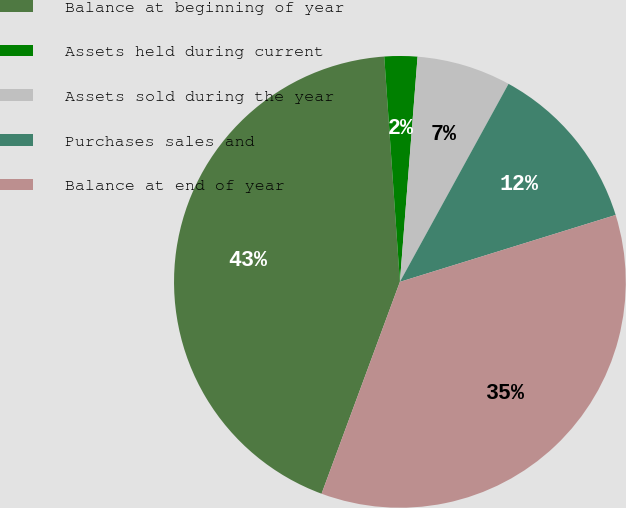Convert chart to OTSL. <chart><loc_0><loc_0><loc_500><loc_500><pie_chart><fcel>Balance at beginning of year<fcel>Assets held during current<fcel>Assets sold during the year<fcel>Purchases sales and<fcel>Balance at end of year<nl><fcel>43.26%<fcel>2.35%<fcel>6.74%<fcel>12.23%<fcel>35.42%<nl></chart> 